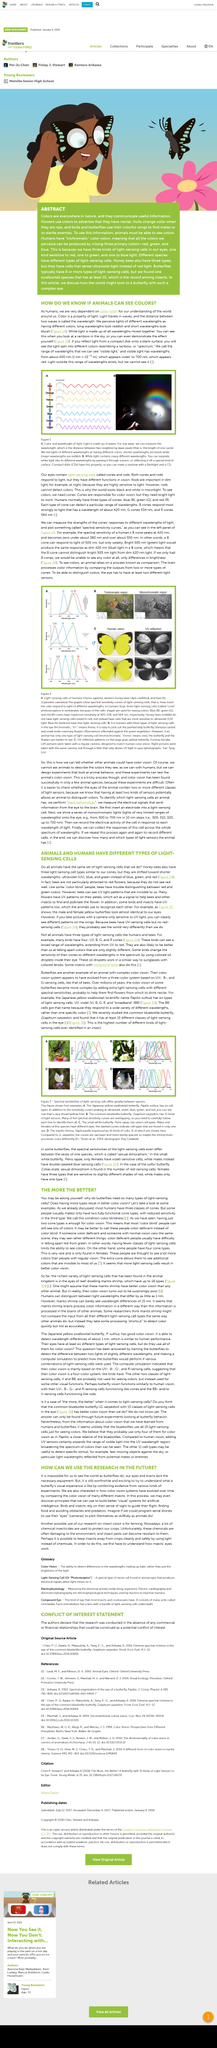Outline some significant characteristics in this image. In the context of biology, the distinction between the physical characteristics that differentiate males and females of the same species is referred to as sexual dimorphism. The human cone cell's peak sensitivity to light is reached at around 380 nm and is absent above 550 nm. It is known that the range of wavelengths that humans can perceive is between 400 nanometers and 700 nanometers. Rainbows are a result of the separation of white light into its different wave lengths, causing a spectrum of colors to appear in the sky. The spectral sensitivity of a human being peaks at 420 nanometers. 